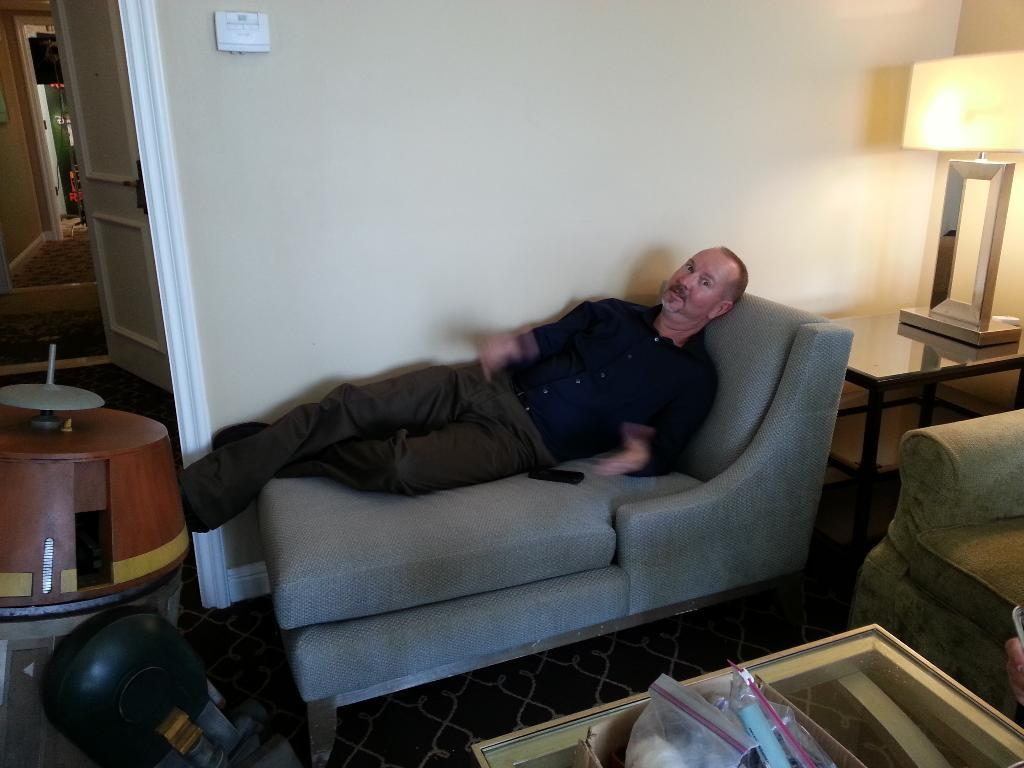What is the man in the image doing? The man is sleeping on a sofa bed in the image. What object can be seen on the right side of the image? There is a bed lamp on the right side of the image. Where is the door located in the image? The door is on the left side of the image. What type of structure is visible in the image? There is a wall visible in the image. How many horses are visible in the image? There are no horses present in the image. What type of organization is responsible for the arrangement of the room in the image? There is no information about an organization responsible for the arrangement of the room in the image. 